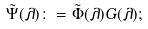Convert formula to latex. <formula><loc_0><loc_0><loc_500><loc_500>\tilde { \Psi } ( \lambda ) \colon = \tilde { \Phi } ( \lambda ) G ( \lambda ) ;</formula> 